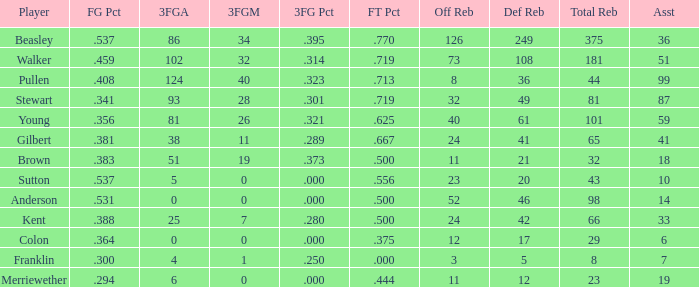How many FG percent values are associated with 59 assists and offensive rebounds under 40? 0.0. 